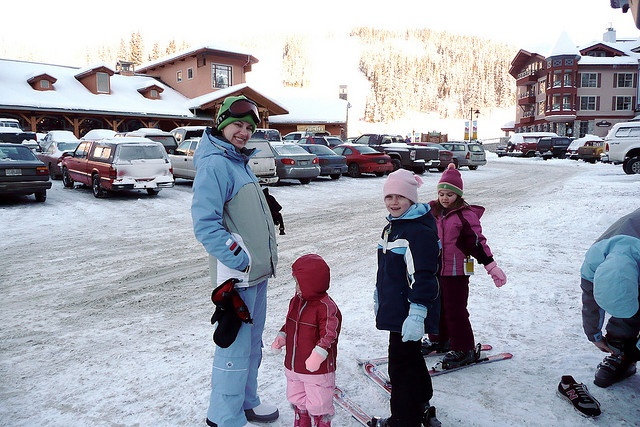Describe the objects in this image and their specific colors. I can see people in white, gray, black, and darkgray tones, people in white, black, darkgray, and gray tones, people in white, black, gray, and navy tones, people in white, maroon, lightpink, darkgray, and pink tones, and people in white, black, purple, and lightgray tones in this image. 